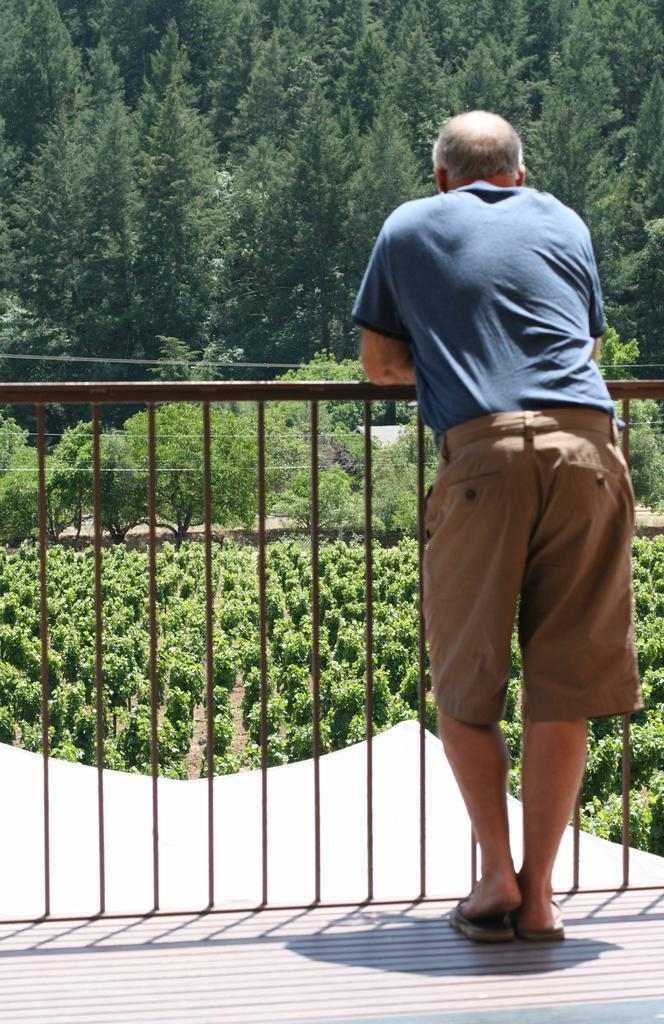What is the main subject in the foreground of the image? There is a person standing in the foreground of the image. What can be seen near the person in the image? There is a railing in the image. What type of natural elements are visible in the background of the image? There are trees and plants in the background of the image. What is the surface that the person is standing on in the image? There is a floor visible at the bottom of the image. What type of cushion is being used to comfort the person in the image? There is no cushion present in the image, and the person's comfort is not mentioned or depicted. 